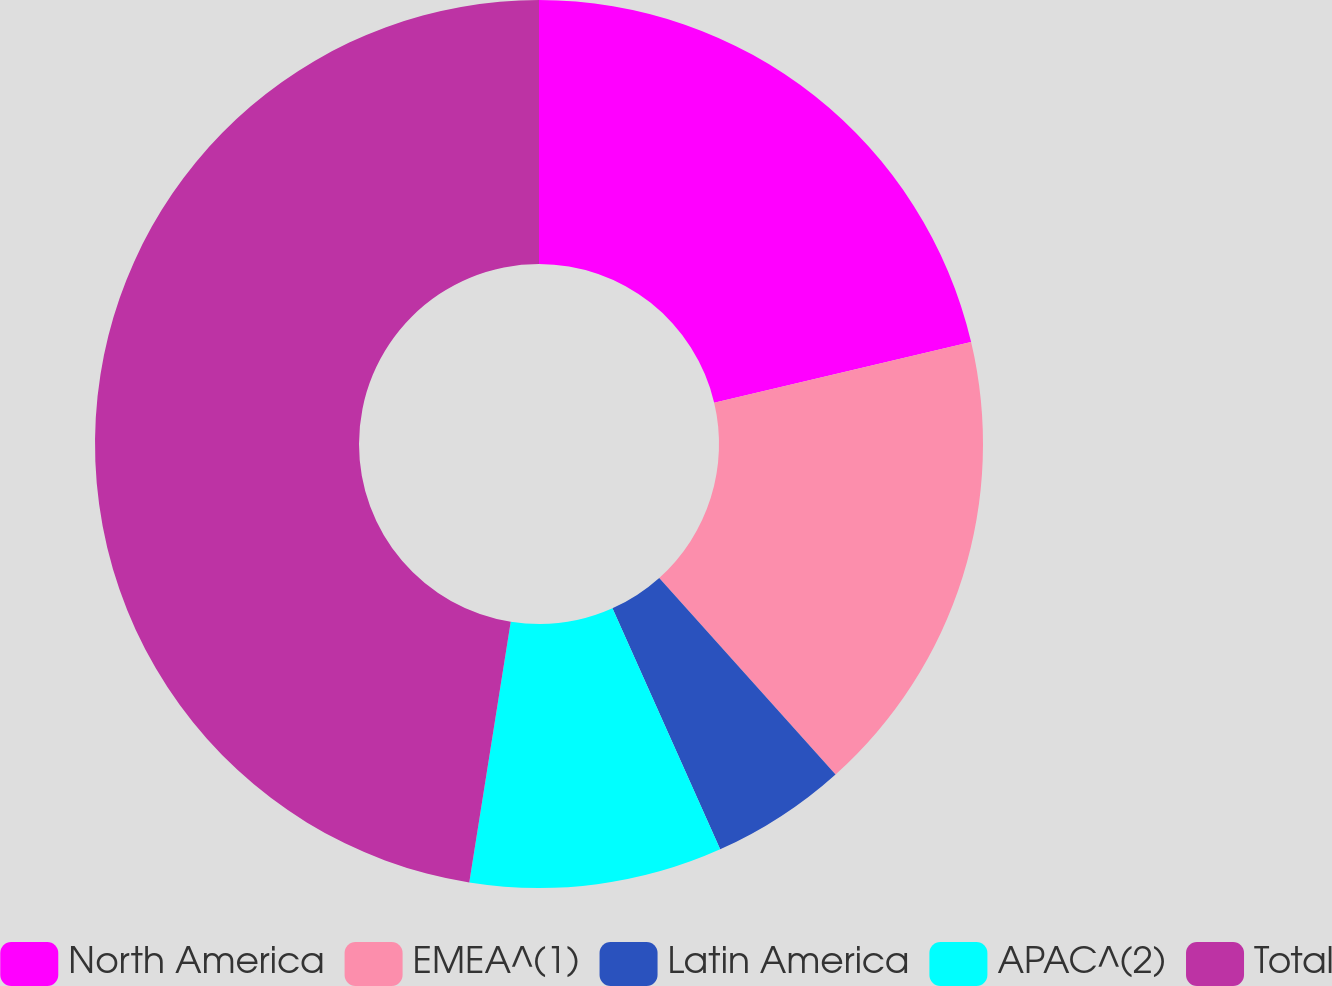Convert chart. <chart><loc_0><loc_0><loc_500><loc_500><pie_chart><fcel>North America<fcel>EMEA^(1)<fcel>Latin America<fcel>APAC^(2)<fcel>Total<nl><fcel>21.31%<fcel>17.05%<fcel>4.95%<fcel>9.2%<fcel>47.49%<nl></chart> 